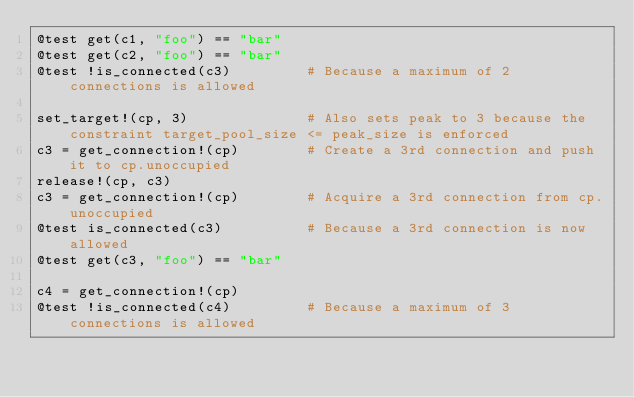Convert code to text. <code><loc_0><loc_0><loc_500><loc_500><_Julia_>@test get(c1, "foo") == "bar"
@test get(c2, "foo") == "bar"
@test !is_connected(c3)         # Because a maximum of 2 connections is allowed

set_target!(cp, 3)              # Also sets peak to 3 because the constraint target_pool_size <= peak_size is enforced
c3 = get_connection!(cp)        # Create a 3rd connection and push it to cp.unoccupied
release!(cp, c3)
c3 = get_connection!(cp)        # Acquire a 3rd connection from cp.unoccupied
@test is_connected(c3)          # Because a 3rd connection is now allowed
@test get(c3, "foo") == "bar"

c4 = get_connection!(cp)
@test !is_connected(c4)         # Because a maximum of 3 connections is allowed</code> 